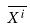<formula> <loc_0><loc_0><loc_500><loc_500>\overline { X ^ { i } }</formula> 